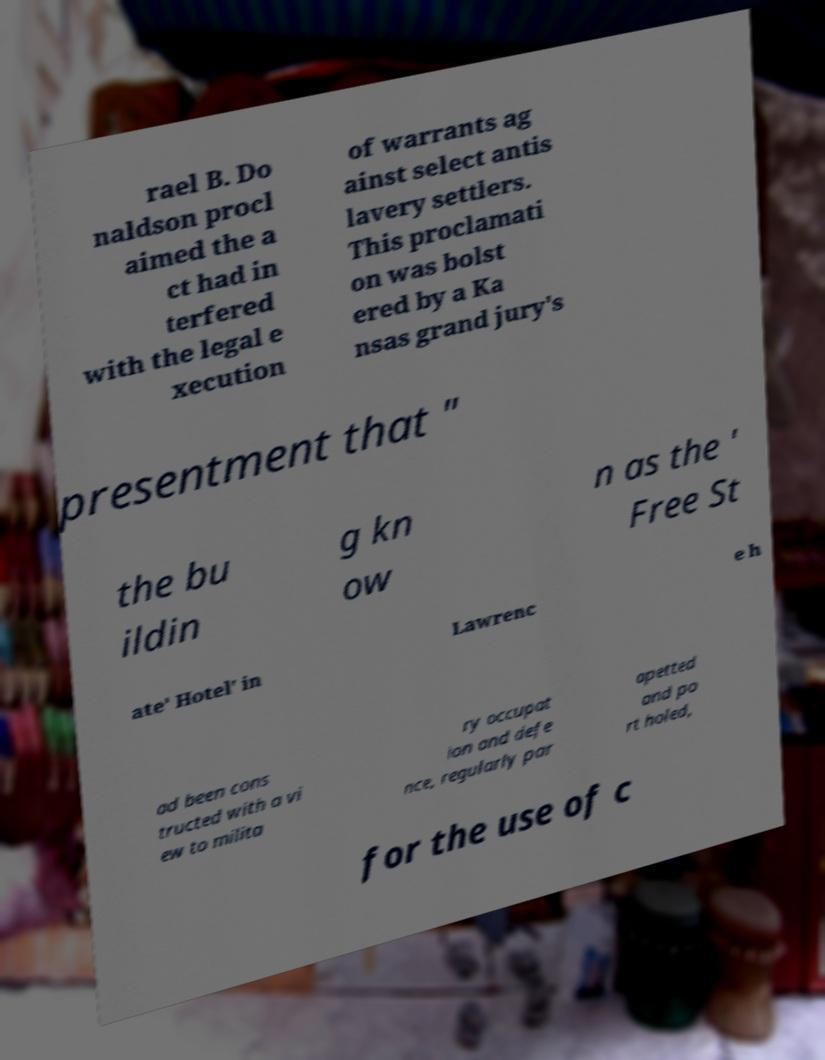I need the written content from this picture converted into text. Can you do that? rael B. Do naldson procl aimed the a ct had in terfered with the legal e xecution of warrants ag ainst select antis lavery settlers. This proclamati on was bolst ered by a Ka nsas grand jury's presentment that " the bu ildin g kn ow n as the ' Free St ate' Hotel' in Lawrenc e h ad been cons tructed with a vi ew to milita ry occupat ion and defe nce, regularly par apetted and po rt holed, for the use of c 